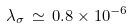Convert formula to latex. <formula><loc_0><loc_0><loc_500><loc_500>\lambda _ { \sigma } \, \simeq \, 0 . 8 \times 1 0 ^ { - 6 }</formula> 